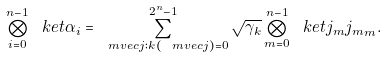Convert formula to latex. <formula><loc_0><loc_0><loc_500><loc_500>\bigotimes _ { i = 0 } ^ { n - 1 } \ k e t { \alpha _ { i } } = \sum _ { \ m v e c { j } \colon k ( \ m v e c { j } ) = 0 } ^ { 2 ^ { n } - 1 } \sqrt { \gamma _ { k } } \bigotimes _ { m = 0 } ^ { n - 1 } \ k e t { j _ { m } j _ { m } } _ { m } .</formula> 